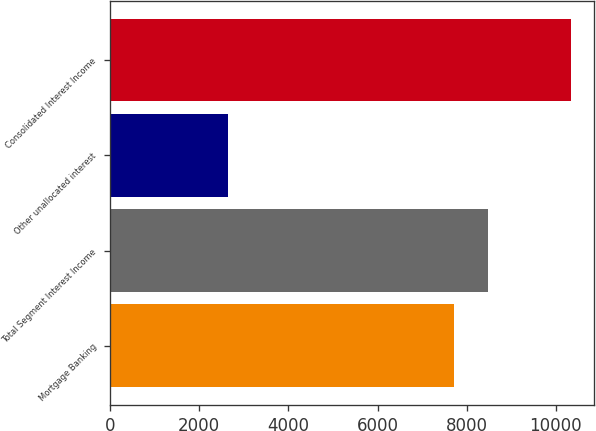Convert chart to OTSL. <chart><loc_0><loc_0><loc_500><loc_500><bar_chart><fcel>Mortgage Banking<fcel>Total Segment Interest Income<fcel>Other unallocated interest<fcel>Consolidated Interest Income<nl><fcel>7704<fcel>8474.4<fcel>2639<fcel>10343<nl></chart> 